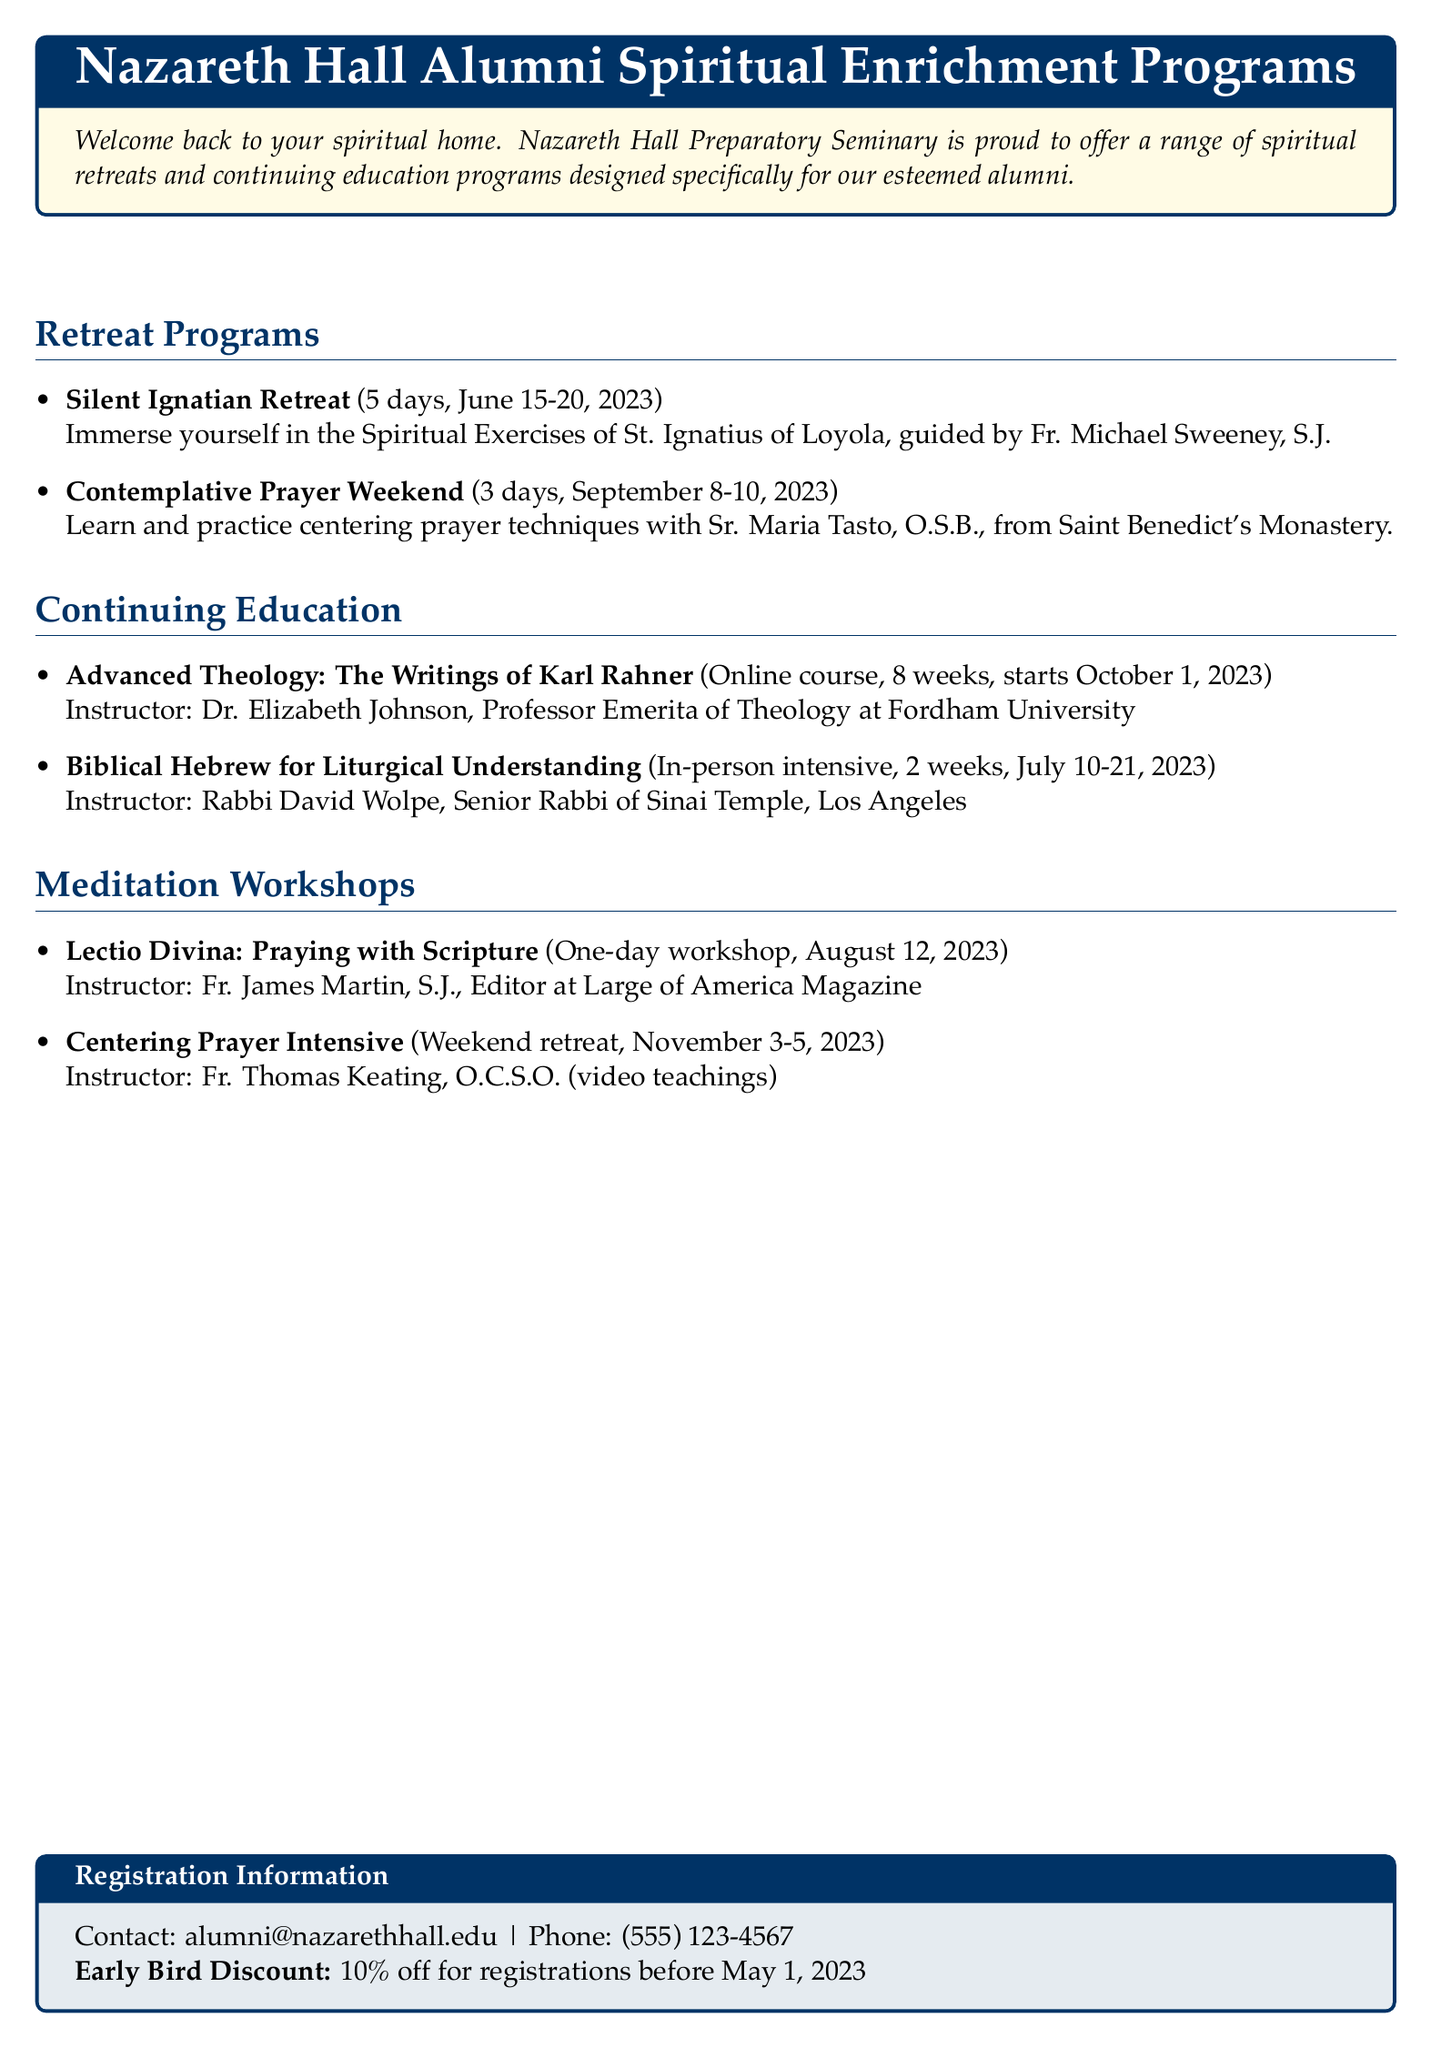What is the name of the retreat on centering prayer techniques? The document lists a Contemplative Prayer Weekend, which focuses on centering prayer techniques.
Answer: Contemplative Prayer Weekend Who is the instructor for the Advanced Theology course? The document states that Dr. Elizabeth Johnson is the instructor for the Advanced Theology course.
Answer: Dr. Elizabeth Johnson When does the Silent Ignatian Retreat take place? The document provides the dates for the Silent Ignatian Retreat as June 15-20, 2023.
Answer: June 15-20, 2023 What percentage is the early bird discount for registrations before May 1, 2023? The document specifies that the early bird discount is 10%.
Answer: 10% How long is the Biblical Hebrew for Liturgical Understanding course? The document states that the course is an in-person intensive lasting 2 weeks.
Answer: 2 weeks Who teaches the Lectio Divina workshop? According to the document, Fr. James Martin, S.J. is the instructor for the Lectio Divina workshop.
Answer: Fr. James Martin, S.J Which retreat is scheduled for November 3-5, 2023? The document identifies the Centering Prayer Intensive as the retreat scheduled for those dates.
Answer: Centering Prayer Intensive What is the contact email for registration information? The document lists the contact email for registration as alumni@nazarethhall.edu.
Answer: alumni@nazarethhall.edu 